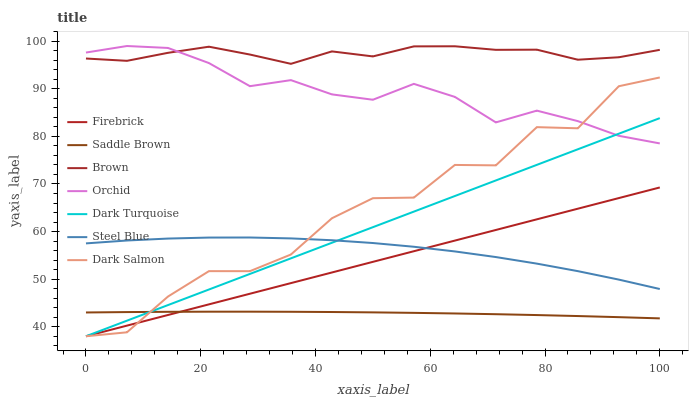Does Saddle Brown have the minimum area under the curve?
Answer yes or no. Yes. Does Brown have the maximum area under the curve?
Answer yes or no. Yes. Does Dark Turquoise have the minimum area under the curve?
Answer yes or no. No. Does Dark Turquoise have the maximum area under the curve?
Answer yes or no. No. Is Dark Turquoise the smoothest?
Answer yes or no. Yes. Is Dark Salmon the roughest?
Answer yes or no. Yes. Is Firebrick the smoothest?
Answer yes or no. No. Is Firebrick the roughest?
Answer yes or no. No. Does Dark Turquoise have the lowest value?
Answer yes or no. Yes. Does Steel Blue have the lowest value?
Answer yes or no. No. Does Orchid have the highest value?
Answer yes or no. Yes. Does Dark Turquoise have the highest value?
Answer yes or no. No. Is Steel Blue less than Orchid?
Answer yes or no. Yes. Is Brown greater than Dark Salmon?
Answer yes or no. Yes. Does Brown intersect Orchid?
Answer yes or no. Yes. Is Brown less than Orchid?
Answer yes or no. No. Is Brown greater than Orchid?
Answer yes or no. No. Does Steel Blue intersect Orchid?
Answer yes or no. No. 